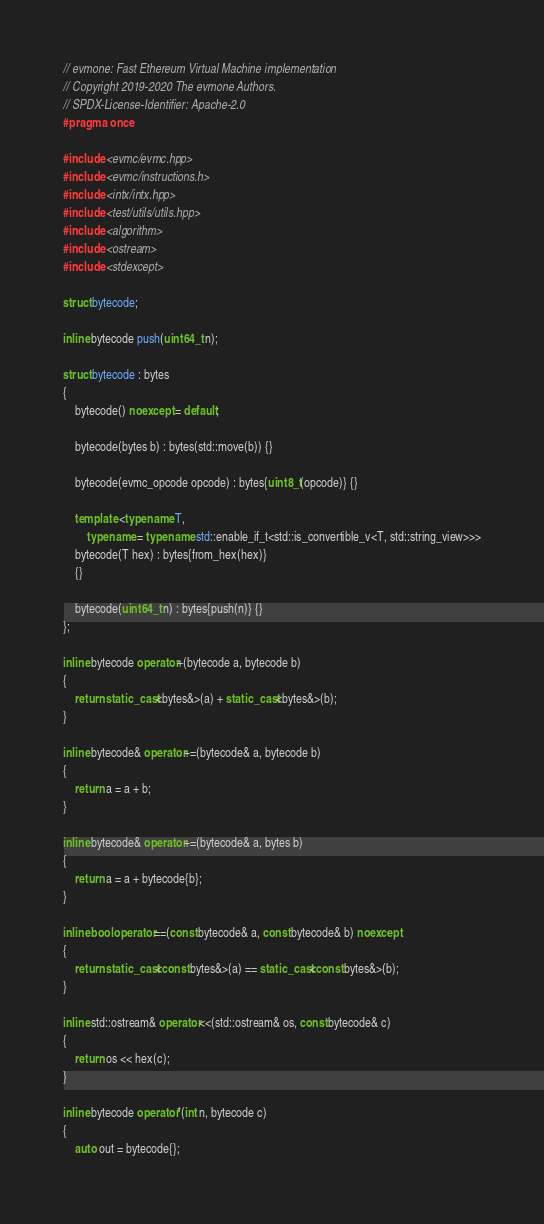<code> <loc_0><loc_0><loc_500><loc_500><_C++_>// evmone: Fast Ethereum Virtual Machine implementation
// Copyright 2019-2020 The evmone Authors.
// SPDX-License-Identifier: Apache-2.0
#pragma once

#include <evmc/evmc.hpp>
#include <evmc/instructions.h>
#include <intx/intx.hpp>
#include <test/utils/utils.hpp>
#include <algorithm>
#include <ostream>
#include <stdexcept>

struct bytecode;

inline bytecode push(uint64_t n);

struct bytecode : bytes
{
    bytecode() noexcept = default;

    bytecode(bytes b) : bytes(std::move(b)) {}

    bytecode(evmc_opcode opcode) : bytes{uint8_t(opcode)} {}

    template <typename T,
        typename = typename std::enable_if_t<std::is_convertible_v<T, std::string_view>>>
    bytecode(T hex) : bytes{from_hex(hex)}
    {}

    bytecode(uint64_t n) : bytes{push(n)} {}
};

inline bytecode operator+(bytecode a, bytecode b)
{
    return static_cast<bytes&>(a) + static_cast<bytes&>(b);
}

inline bytecode& operator+=(bytecode& a, bytecode b)
{
    return a = a + b;
}

inline bytecode& operator+=(bytecode& a, bytes b)
{
    return a = a + bytecode{b};
}

inline bool operator==(const bytecode& a, const bytecode& b) noexcept
{
    return static_cast<const bytes&>(a) == static_cast<const bytes&>(b);
}

inline std::ostream& operator<<(std::ostream& os, const bytecode& c)
{
    return os << hex(c);
}

inline bytecode operator*(int n, bytecode c)
{
    auto out = bytecode{};</code> 